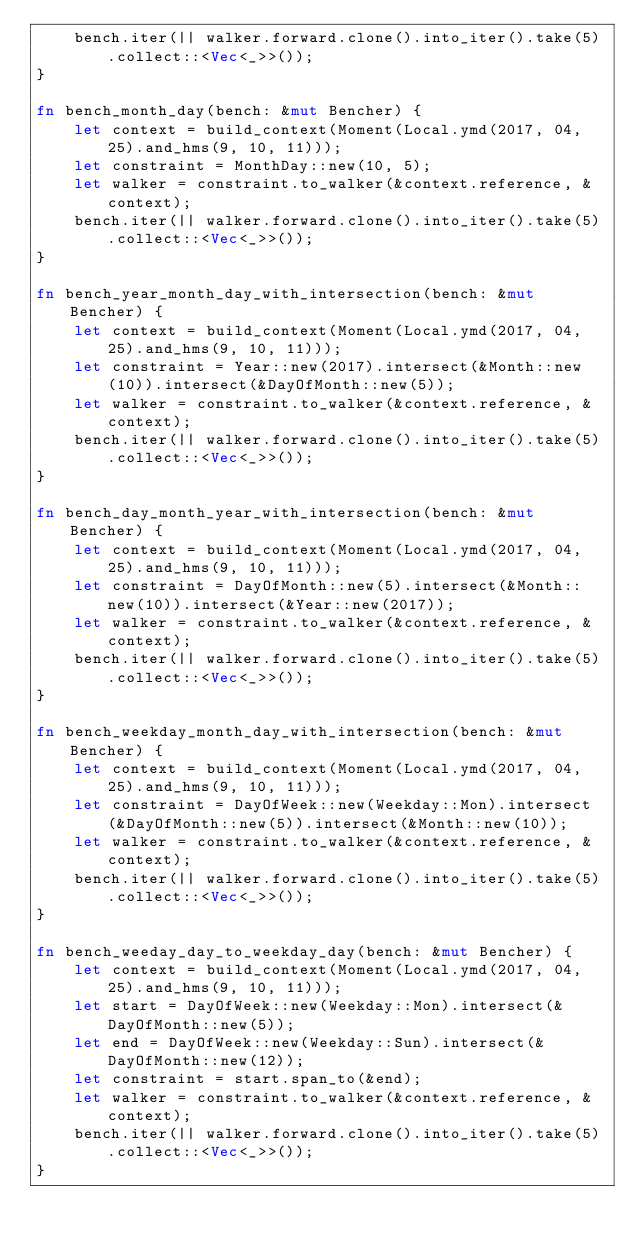<code> <loc_0><loc_0><loc_500><loc_500><_Rust_>    bench.iter(|| walker.forward.clone().into_iter().take(5).collect::<Vec<_>>());
}

fn bench_month_day(bench: &mut Bencher) {
    let context = build_context(Moment(Local.ymd(2017, 04, 25).and_hms(9, 10, 11)));
    let constraint = MonthDay::new(10, 5);
    let walker = constraint.to_walker(&context.reference, &context);
    bench.iter(|| walker.forward.clone().into_iter().take(5).collect::<Vec<_>>());
}

fn bench_year_month_day_with_intersection(bench: &mut Bencher) {
    let context = build_context(Moment(Local.ymd(2017, 04, 25).and_hms(9, 10, 11)));
    let constraint = Year::new(2017).intersect(&Month::new(10)).intersect(&DayOfMonth::new(5));
    let walker = constraint.to_walker(&context.reference, &context);
    bench.iter(|| walker.forward.clone().into_iter().take(5).collect::<Vec<_>>());
}

fn bench_day_month_year_with_intersection(bench: &mut Bencher) {
    let context = build_context(Moment(Local.ymd(2017, 04, 25).and_hms(9, 10, 11)));
    let constraint = DayOfMonth::new(5).intersect(&Month::new(10)).intersect(&Year::new(2017));
    let walker = constraint.to_walker(&context.reference, &context);
    bench.iter(|| walker.forward.clone().into_iter().take(5).collect::<Vec<_>>());
}

fn bench_weekday_month_day_with_intersection(bench: &mut Bencher) {
    let context = build_context(Moment(Local.ymd(2017, 04, 25).and_hms(9, 10, 11)));
    let constraint = DayOfWeek::new(Weekday::Mon).intersect(&DayOfMonth::new(5)).intersect(&Month::new(10));
    let walker = constraint.to_walker(&context.reference, &context);
    bench.iter(|| walker.forward.clone().into_iter().take(5).collect::<Vec<_>>());
}

fn bench_weeday_day_to_weekday_day(bench: &mut Bencher) {
    let context = build_context(Moment(Local.ymd(2017, 04, 25).and_hms(9, 10, 11)));
    let start = DayOfWeek::new(Weekday::Mon).intersect(&DayOfMonth::new(5));
    let end = DayOfWeek::new(Weekday::Sun).intersect(&DayOfMonth::new(12));
    let constraint = start.span_to(&end);
    let walker = constraint.to_walker(&context.reference, &context);
    bench.iter(|| walker.forward.clone().into_iter().take(5).collect::<Vec<_>>());
}
</code> 